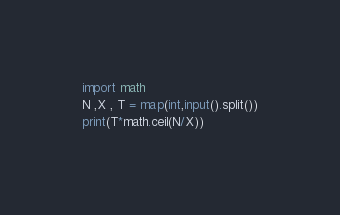Convert code to text. <code><loc_0><loc_0><loc_500><loc_500><_Python_>import math
N ,X , T = map(int,input().split())
print(T*math.ceil(N/X))</code> 